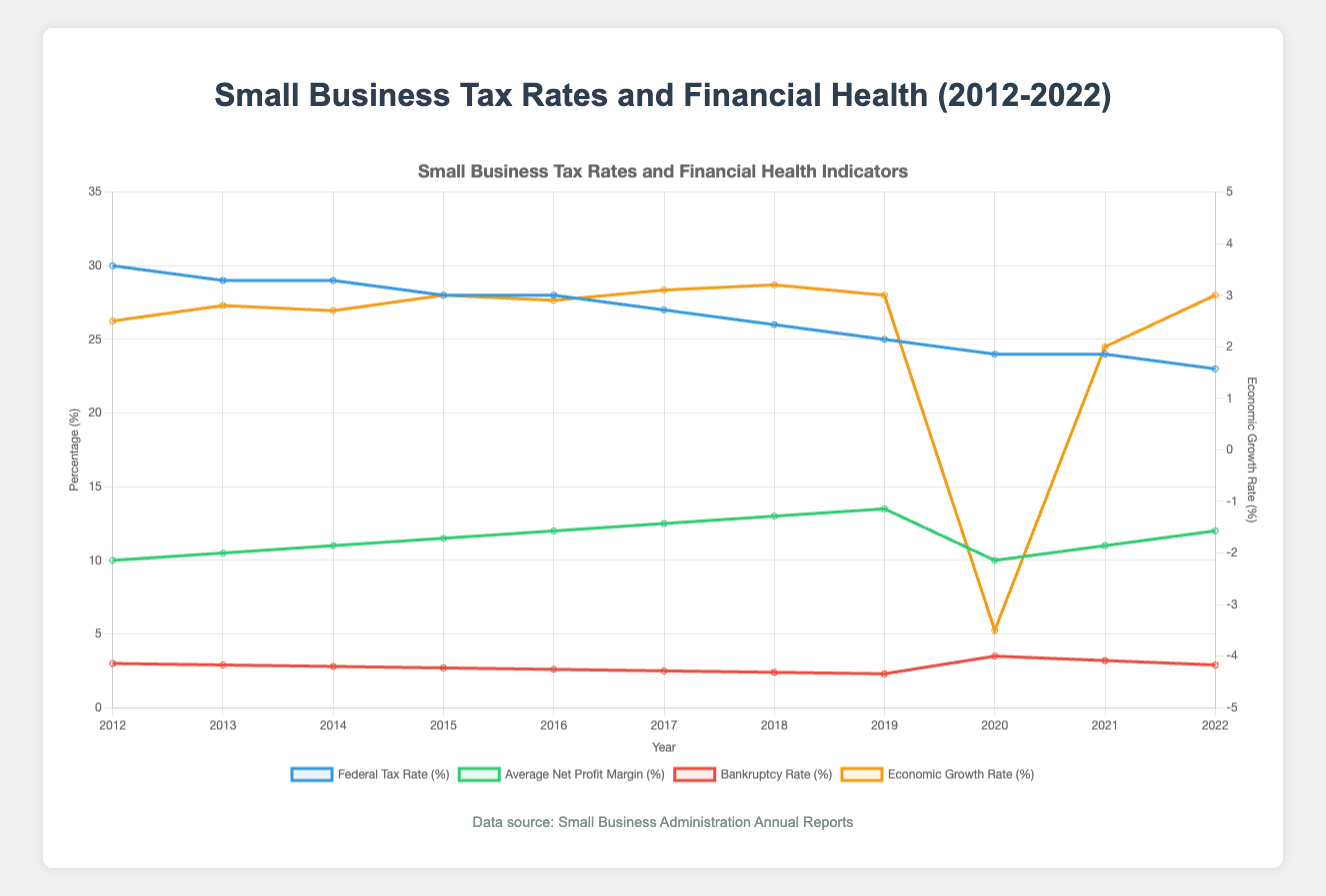What year had the highest federal tax rate? The highest federal tax rate can be determined by examining the peak point of the "Federal Tax Rate (%)" line on the graph.
Answer: 2012 Compare the bankruptcy rates in 2012 and 2022. Which year had a higher rate? To compare the bankruptcy rates, locate the points on the "Bankruptcy Rate (%)" line for the years 2012 and 2022, and compare their heights.
Answer: 2012 What was the average net profit margin in 2020? The average net profit margin in 2020 is given by the value of the "Average Net Profit Margin (%)" line at the year 2020.
Answer: 10 Calculate the difference in the number of small businesses between 2019 and 2020. Find the number of small businesses in 2019 and 2020 on the "Number of Small Businesses" line and subtract the 2020 value from the 2019 value.
Answer: 45,000 When did the economic growth rate first become negative, and what was the rate? Locate the first point where the "Economic Growth Rate (%)" line dips below 0 and read the value for that year.
Answer: 2020, -3.5 How did the local tax rate change from 2012 to 2022? Find the values of the "Local Tax Rate (%)" line for the years 2012 and 2022 and compare them.
Answer: Decreased by 0.5% Which year had the lowest combination of federal and state tax rates? Sum the values of the "Federal Tax Rate (%)" and "State Tax Rate (%)" lines for each year, and identify the minimum total.
Answer: 2022 Compare 2017 and 2018 in terms of average net profit margin. Which year was higher and by how much? Read the values of the "Average Net Profit Margin (%)" line for 2017 and 2018, subtract the 2017 value from the 2018 value to find the difference.
Answer: 2018, higher by 0.5% What was the trend in the number of small businesses from 2012 to 2019? Observe the "Number of Small Businesses" line from 2012 to 2019 and describe the overall direction of movement.
Answer: Increasing trend Identify the year with the highest economic growth rate and state the rate. Locate the peak point on the "Economic Growth Rate (%)" line and note the value for that year.
Answer: 2018, 3.2% 